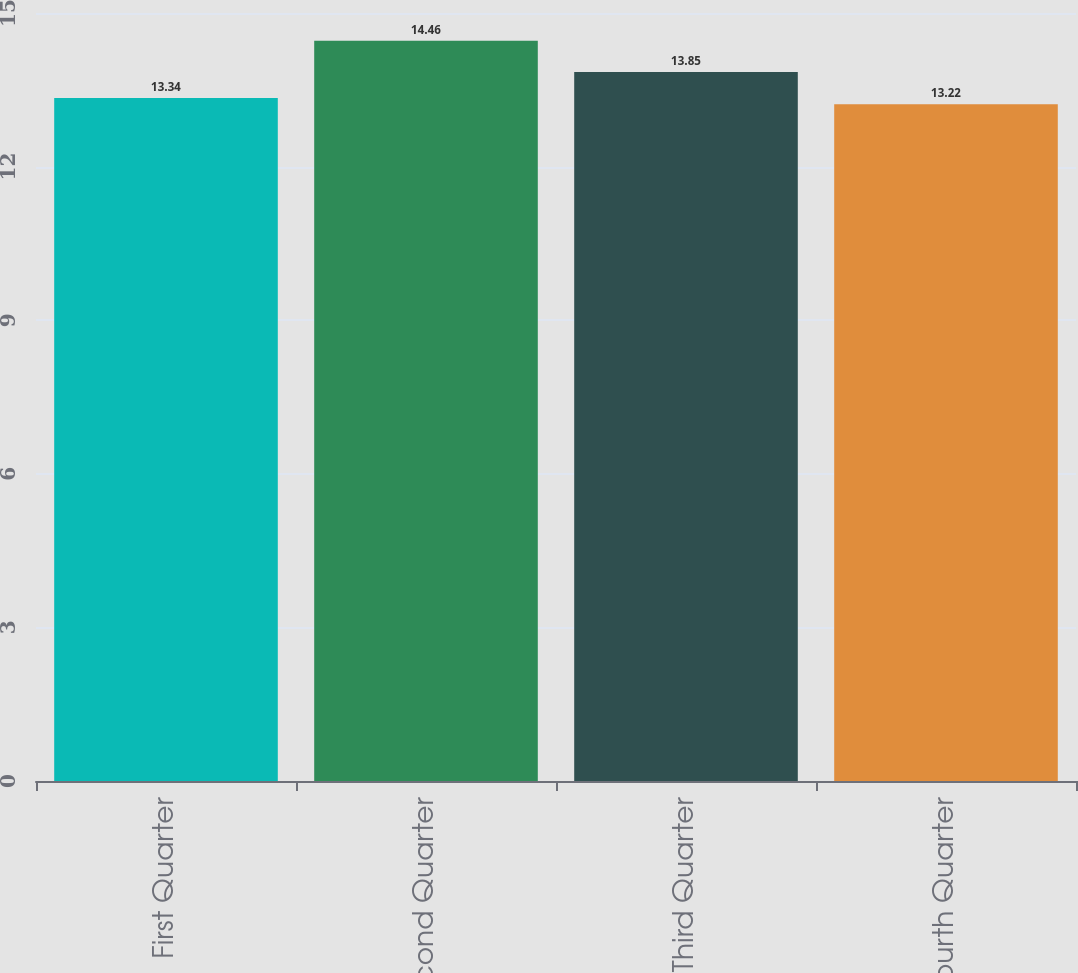Convert chart. <chart><loc_0><loc_0><loc_500><loc_500><bar_chart><fcel>First Quarter<fcel>Second Quarter<fcel>Third Quarter<fcel>Fourth Quarter<nl><fcel>13.34<fcel>14.46<fcel>13.85<fcel>13.22<nl></chart> 